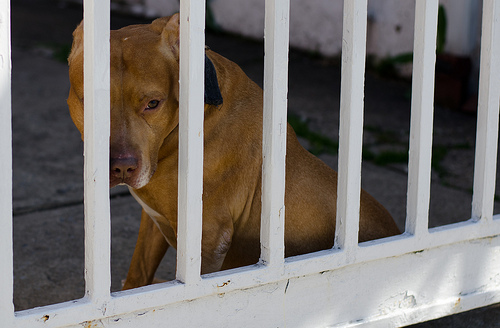<image>
Is there a dog in front of the gate? No. The dog is not in front of the gate. The spatial positioning shows a different relationship between these objects. Where is the dog in relation to the fence? Is it in front of the fence? No. The dog is not in front of the fence. The spatial positioning shows a different relationship between these objects. 